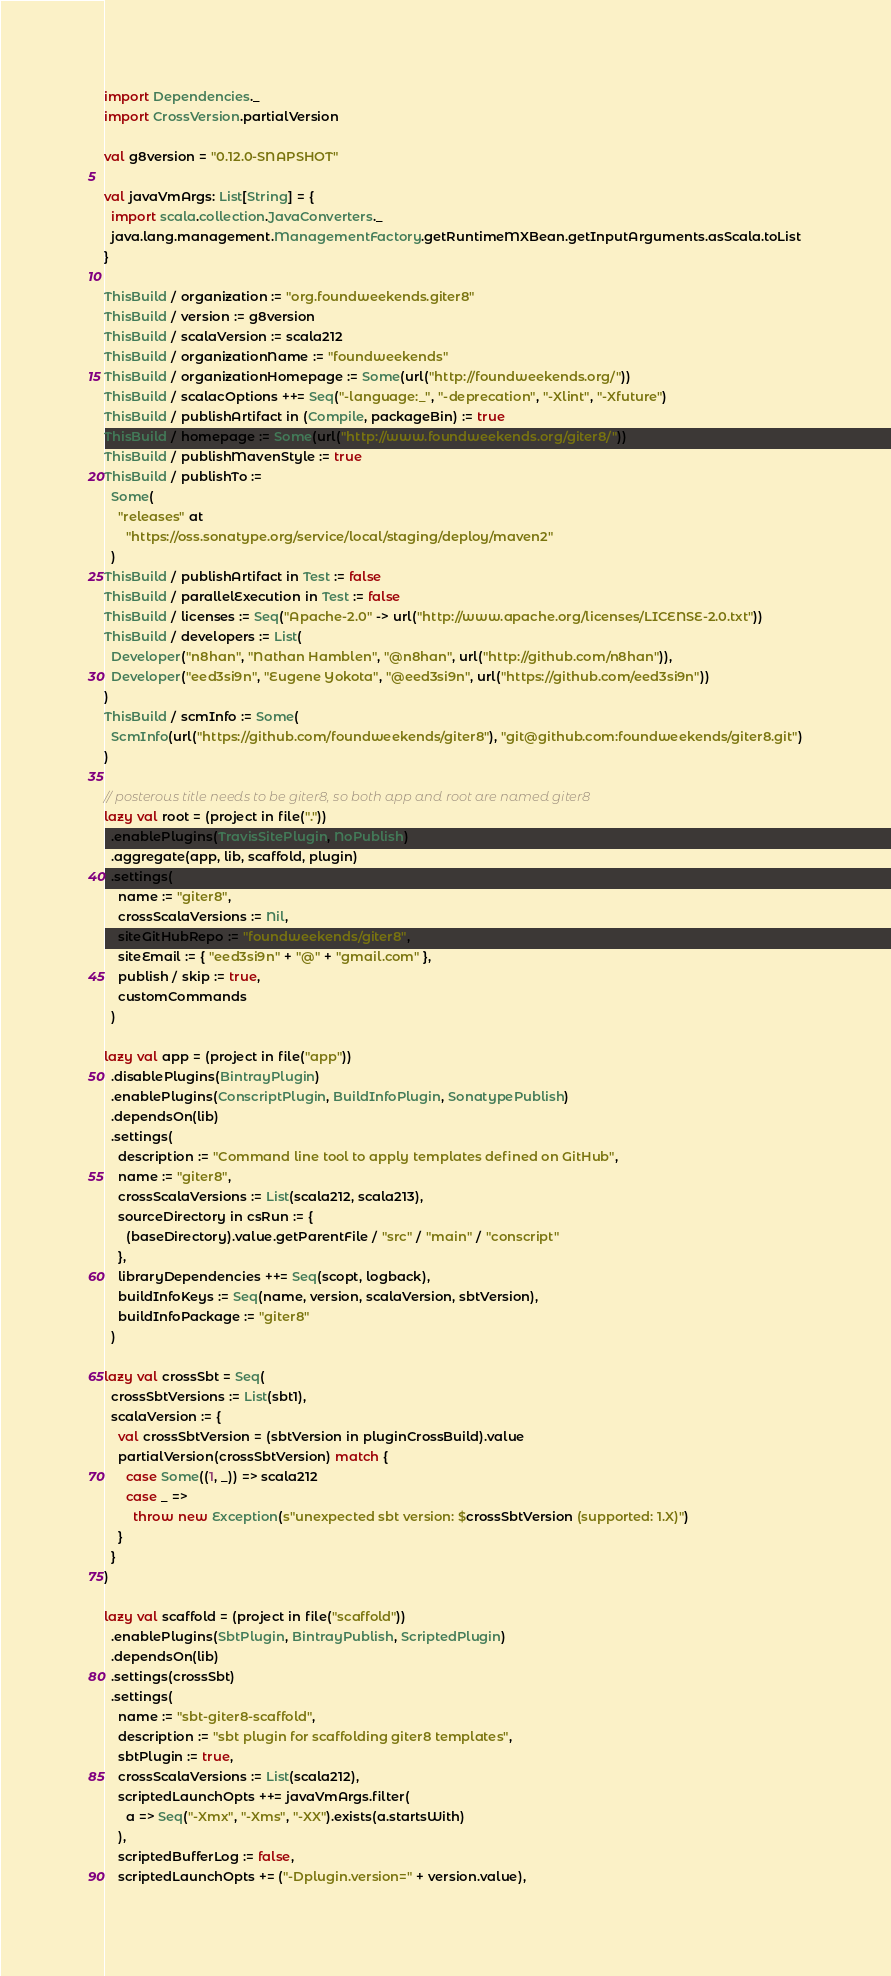Convert code to text. <code><loc_0><loc_0><loc_500><loc_500><_Scala_>import Dependencies._
import CrossVersion.partialVersion

val g8version = "0.12.0-SNAPSHOT"

val javaVmArgs: List[String] = {
  import scala.collection.JavaConverters._
  java.lang.management.ManagementFactory.getRuntimeMXBean.getInputArguments.asScala.toList
}

ThisBuild / organization := "org.foundweekends.giter8"
ThisBuild / version := g8version
ThisBuild / scalaVersion := scala212
ThisBuild / organizationName := "foundweekends"
ThisBuild / organizationHomepage := Some(url("http://foundweekends.org/"))
ThisBuild / scalacOptions ++= Seq("-language:_", "-deprecation", "-Xlint", "-Xfuture")
ThisBuild / publishArtifact in (Compile, packageBin) := true
ThisBuild / homepage := Some(url("http://www.foundweekends.org/giter8/"))
ThisBuild / publishMavenStyle := true
ThisBuild / publishTo :=
  Some(
    "releases" at
      "https://oss.sonatype.org/service/local/staging/deploy/maven2"
  )
ThisBuild / publishArtifact in Test := false
ThisBuild / parallelExecution in Test := false
ThisBuild / licenses := Seq("Apache-2.0" -> url("http://www.apache.org/licenses/LICENSE-2.0.txt"))
ThisBuild / developers := List(
  Developer("n8han", "Nathan Hamblen", "@n8han", url("http://github.com/n8han")),
  Developer("eed3si9n", "Eugene Yokota", "@eed3si9n", url("https://github.com/eed3si9n"))
)
ThisBuild / scmInfo := Some(
  ScmInfo(url("https://github.com/foundweekends/giter8"), "git@github.com:foundweekends/giter8.git")
)

// posterous title needs to be giter8, so both app and root are named giter8
lazy val root = (project in file("."))
  .enablePlugins(TravisSitePlugin, NoPublish)
  .aggregate(app, lib, scaffold, plugin)
  .settings(
    name := "giter8",
    crossScalaVersions := Nil,
    siteGitHubRepo := "foundweekends/giter8",
    siteEmail := { "eed3si9n" + "@" + "gmail.com" },
    publish / skip := true,
    customCommands
  )

lazy val app = (project in file("app"))
  .disablePlugins(BintrayPlugin)
  .enablePlugins(ConscriptPlugin, BuildInfoPlugin, SonatypePublish)
  .dependsOn(lib)
  .settings(
    description := "Command line tool to apply templates defined on GitHub",
    name := "giter8",
    crossScalaVersions := List(scala212, scala213),
    sourceDirectory in csRun := {
      (baseDirectory).value.getParentFile / "src" / "main" / "conscript"
    },
    libraryDependencies ++= Seq(scopt, logback),
    buildInfoKeys := Seq(name, version, scalaVersion, sbtVersion),
    buildInfoPackage := "giter8"
  )

lazy val crossSbt = Seq(
  crossSbtVersions := List(sbt1),
  scalaVersion := {
    val crossSbtVersion = (sbtVersion in pluginCrossBuild).value
    partialVersion(crossSbtVersion) match {
      case Some((1, _)) => scala212
      case _ =>
        throw new Exception(s"unexpected sbt version: $crossSbtVersion (supported: 1.X)")
    }
  }
)

lazy val scaffold = (project in file("scaffold"))
  .enablePlugins(SbtPlugin, BintrayPublish, ScriptedPlugin)
  .dependsOn(lib)
  .settings(crossSbt)
  .settings(
    name := "sbt-giter8-scaffold",
    description := "sbt plugin for scaffolding giter8 templates",
    sbtPlugin := true,
    crossScalaVersions := List(scala212),
    scriptedLaunchOpts ++= javaVmArgs.filter(
      a => Seq("-Xmx", "-Xms", "-XX").exists(a.startsWith)
    ),
    scriptedBufferLog := false,
    scriptedLaunchOpts += ("-Dplugin.version=" + version.value),</code> 